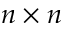<formula> <loc_0><loc_0><loc_500><loc_500>n \times n</formula> 